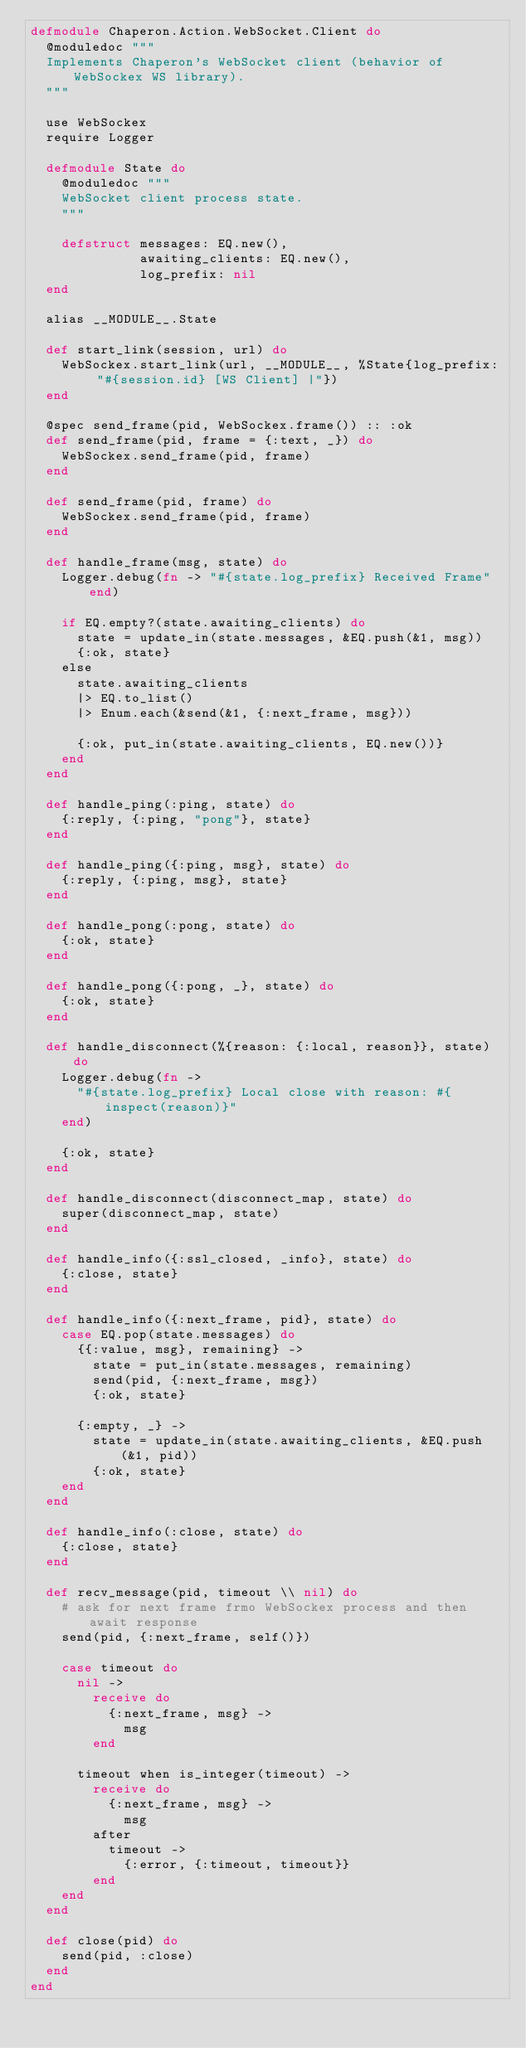<code> <loc_0><loc_0><loc_500><loc_500><_Elixir_>defmodule Chaperon.Action.WebSocket.Client do
  @moduledoc """
  Implements Chaperon's WebSocket client (behavior of WebSockex WS library).
  """

  use WebSockex
  require Logger

  defmodule State do
    @moduledoc """
    WebSocket client process state.
    """

    defstruct messages: EQ.new(),
              awaiting_clients: EQ.new(),
              log_prefix: nil
  end

  alias __MODULE__.State

  def start_link(session, url) do
    WebSockex.start_link(url, __MODULE__, %State{log_prefix: "#{session.id} [WS Client] |"})
  end

  @spec send_frame(pid, WebSockex.frame()) :: :ok
  def send_frame(pid, frame = {:text, _}) do
    WebSockex.send_frame(pid, frame)
  end

  def send_frame(pid, frame) do
    WebSockex.send_frame(pid, frame)
  end

  def handle_frame(msg, state) do
    Logger.debug(fn -> "#{state.log_prefix} Received Frame" end)

    if EQ.empty?(state.awaiting_clients) do
      state = update_in(state.messages, &EQ.push(&1, msg))
      {:ok, state}
    else
      state.awaiting_clients
      |> EQ.to_list()
      |> Enum.each(&send(&1, {:next_frame, msg}))

      {:ok, put_in(state.awaiting_clients, EQ.new())}
    end
  end

  def handle_ping(:ping, state) do
    {:reply, {:ping, "pong"}, state}
  end

  def handle_ping({:ping, msg}, state) do
    {:reply, {:ping, msg}, state}
  end

  def handle_pong(:pong, state) do
    {:ok, state}
  end

  def handle_pong({:pong, _}, state) do
    {:ok, state}
  end

  def handle_disconnect(%{reason: {:local, reason}}, state) do
    Logger.debug(fn ->
      "#{state.log_prefix} Local close with reason: #{inspect(reason)}"
    end)

    {:ok, state}
  end

  def handle_disconnect(disconnect_map, state) do
    super(disconnect_map, state)
  end

  def handle_info({:ssl_closed, _info}, state) do
    {:close, state}
  end

  def handle_info({:next_frame, pid}, state) do
    case EQ.pop(state.messages) do
      {{:value, msg}, remaining} ->
        state = put_in(state.messages, remaining)
        send(pid, {:next_frame, msg})
        {:ok, state}

      {:empty, _} ->
        state = update_in(state.awaiting_clients, &EQ.push(&1, pid))
        {:ok, state}
    end
  end

  def handle_info(:close, state) do
    {:close, state}
  end

  def recv_message(pid, timeout \\ nil) do
    # ask for next frame frmo WebSockex process and then await response
    send(pid, {:next_frame, self()})

    case timeout do
      nil ->
        receive do
          {:next_frame, msg} ->
            msg
        end

      timeout when is_integer(timeout) ->
        receive do
          {:next_frame, msg} ->
            msg
        after
          timeout ->
            {:error, {:timeout, timeout}}
        end
    end
  end

  def close(pid) do
    send(pid, :close)
  end
end
</code> 